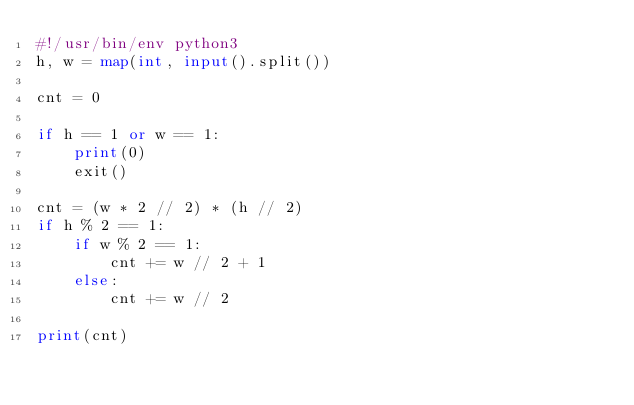<code> <loc_0><loc_0><loc_500><loc_500><_Python_>#!/usr/bin/env python3
h, w = map(int, input().split())

cnt = 0

if h == 1 or w == 1:
    print(0)
    exit()

cnt = (w * 2 // 2) * (h // 2)
if h % 2 == 1:
    if w % 2 == 1:
        cnt += w // 2 + 1
    else:
        cnt += w // 2

print(cnt)
</code> 